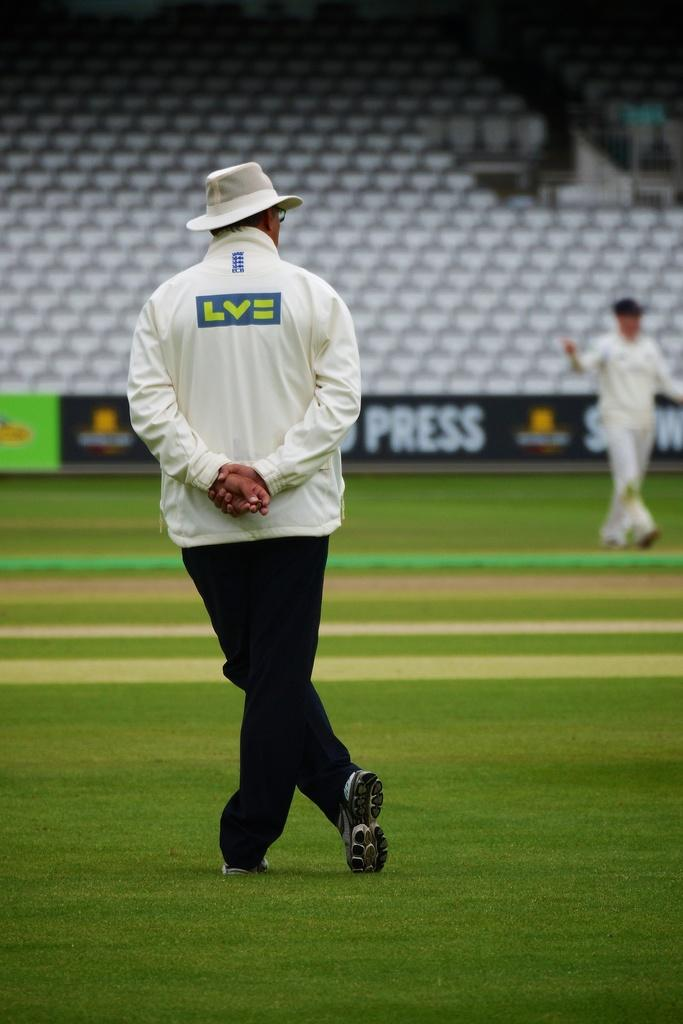What type of location is depicted in the image? The image shows an inside view of a stadium. What can be found inside the stadium? There are chairs in the stadium. Is there any signage or decoration visible in the image? Yes, there is a wall with a banner in the stadium. Are there any people present in the image? Yes, two people are standing on the ground inside the stadium. What type of cake is being served to the passengers in the image? There is no cake or passengers present in the image; it shows an inside view of a stadium with chairs, a banner, and two people standing on the ground. What is the purpose of the protest taking place inside the stadium in the image? There is no protest or indication of any protest-related activity in the image; it shows an inside view of a stadium with chairs, a banner, and two people standing on the ground. 